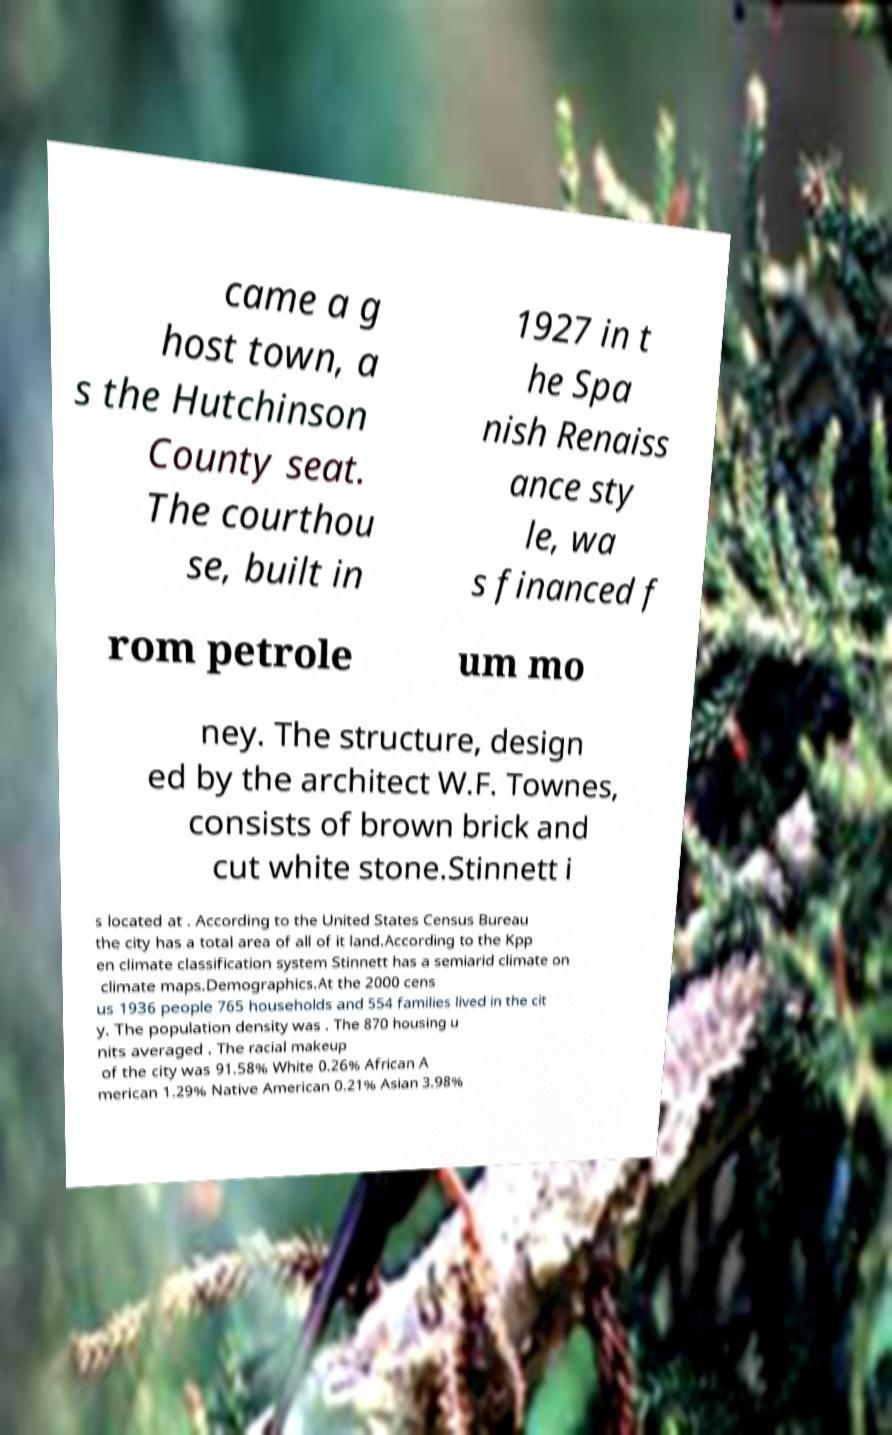Can you accurately transcribe the text from the provided image for me? came a g host town, a s the Hutchinson County seat. The courthou se, built in 1927 in t he Spa nish Renaiss ance sty le, wa s financed f rom petrole um mo ney. The structure, design ed by the architect W.F. Townes, consists of brown brick and cut white stone.Stinnett i s located at . According to the United States Census Bureau the city has a total area of all of it land.According to the Kpp en climate classification system Stinnett has a semiarid climate on climate maps.Demographics.At the 2000 cens us 1936 people 765 households and 554 families lived in the cit y. The population density was . The 870 housing u nits averaged . The racial makeup of the city was 91.58% White 0.26% African A merican 1.29% Native American 0.21% Asian 3.98% 